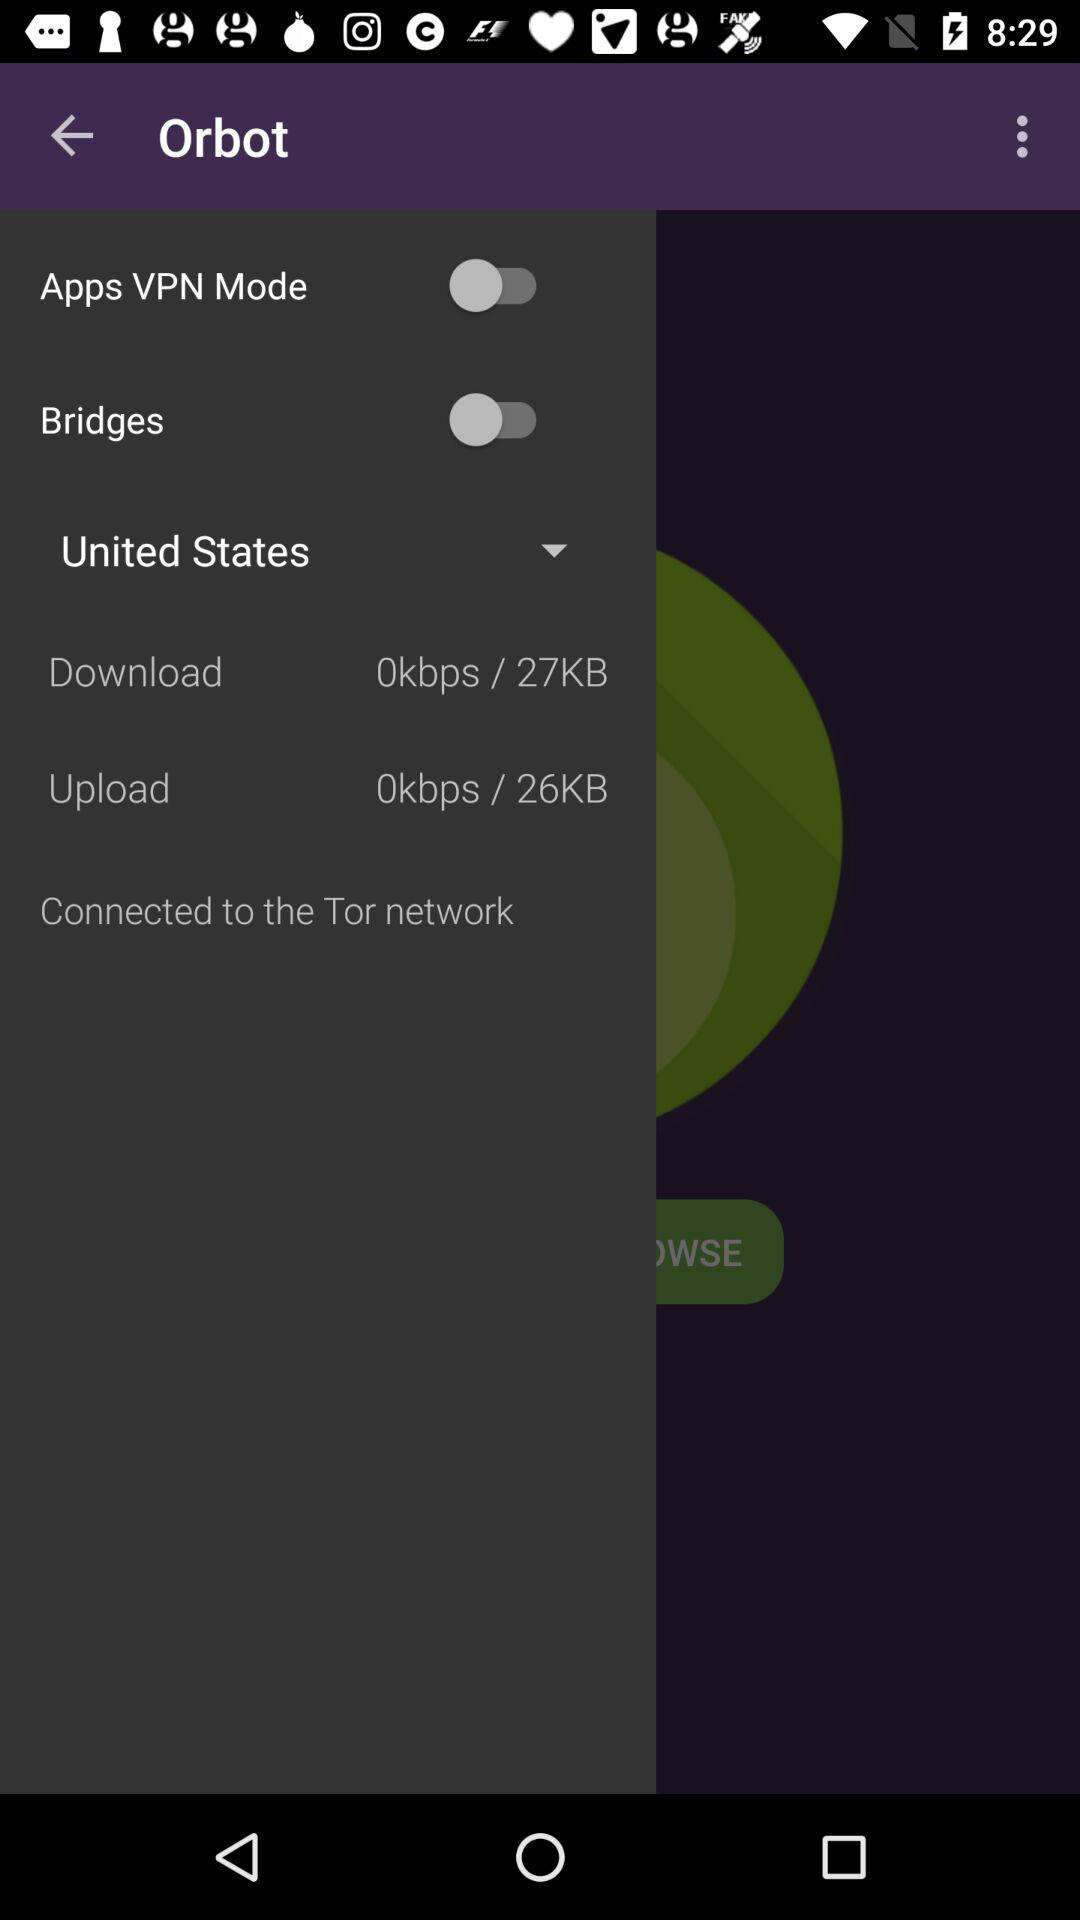What is the download speed? The download speed is 0 kbps. 